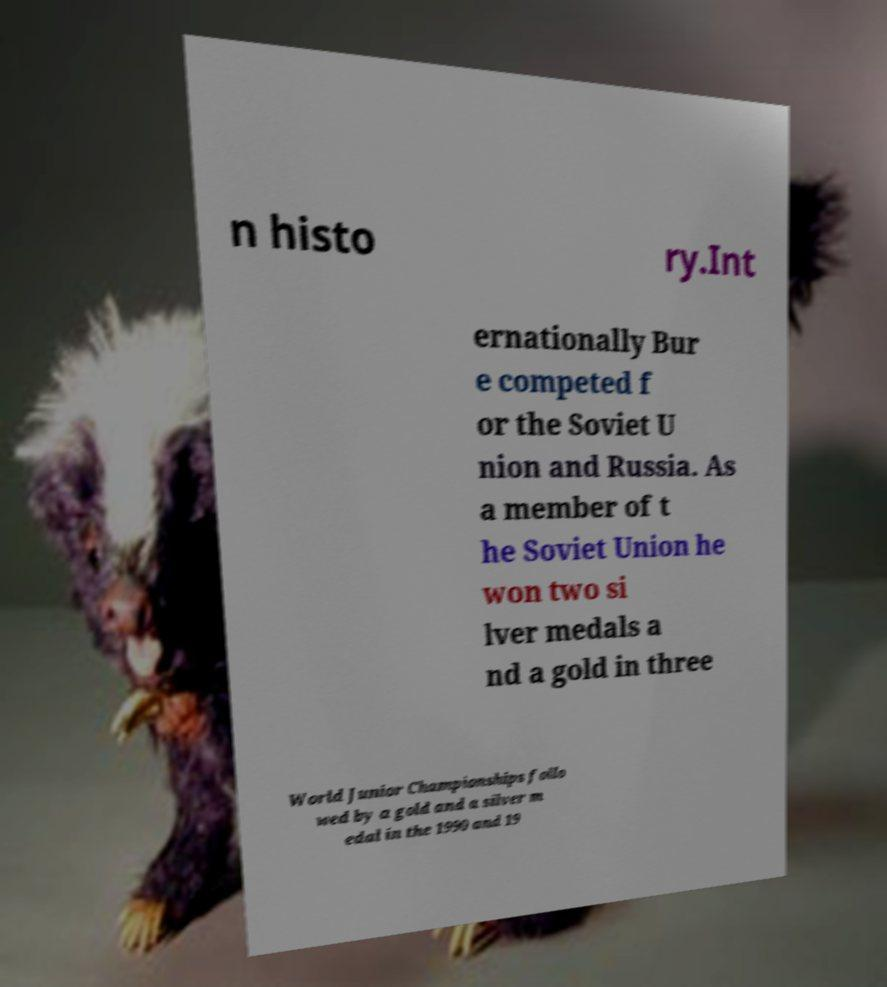Could you assist in decoding the text presented in this image and type it out clearly? n histo ry.Int ernationally Bur e competed f or the Soviet U nion and Russia. As a member of t he Soviet Union he won two si lver medals a nd a gold in three World Junior Championships follo wed by a gold and a silver m edal in the 1990 and 19 